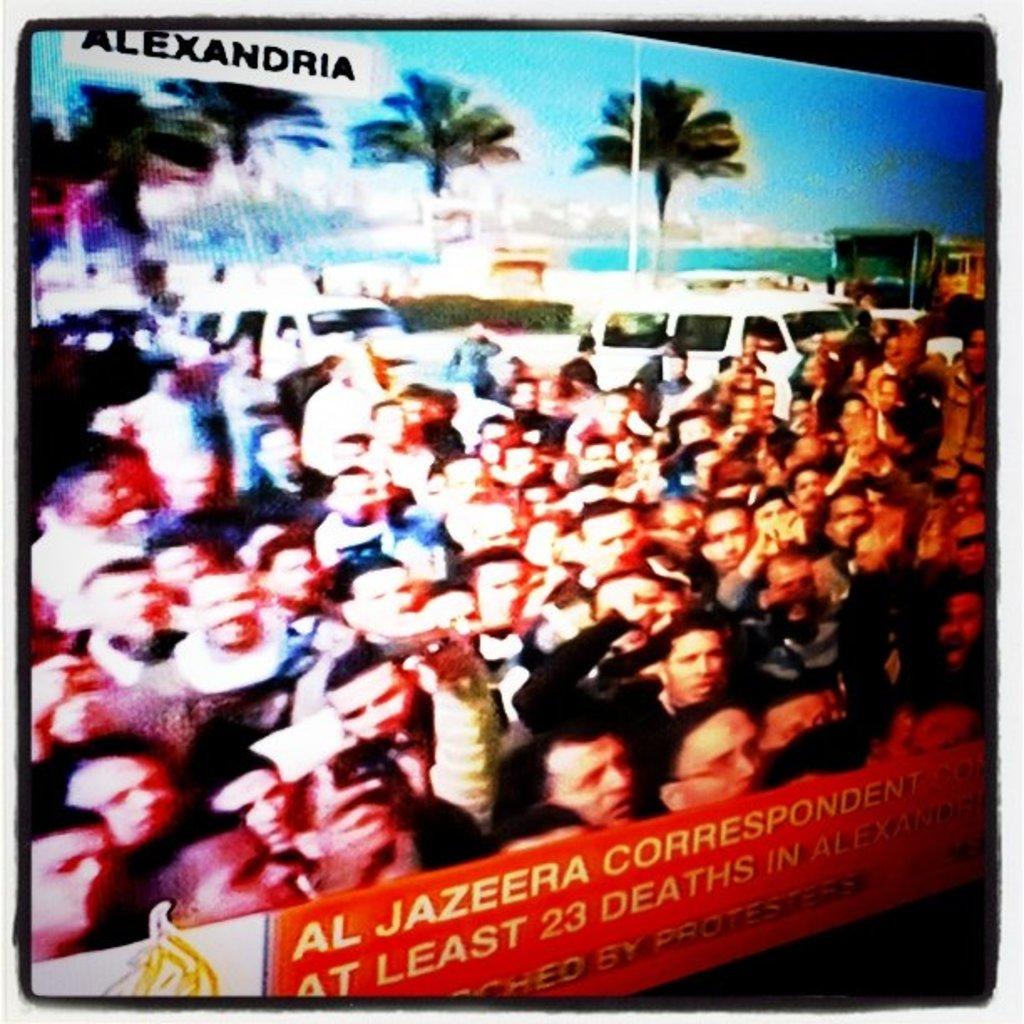What does it say on the top left corner?
Your answer should be very brief. Alexandria. How many deaths?
Ensure brevity in your answer.  23. 